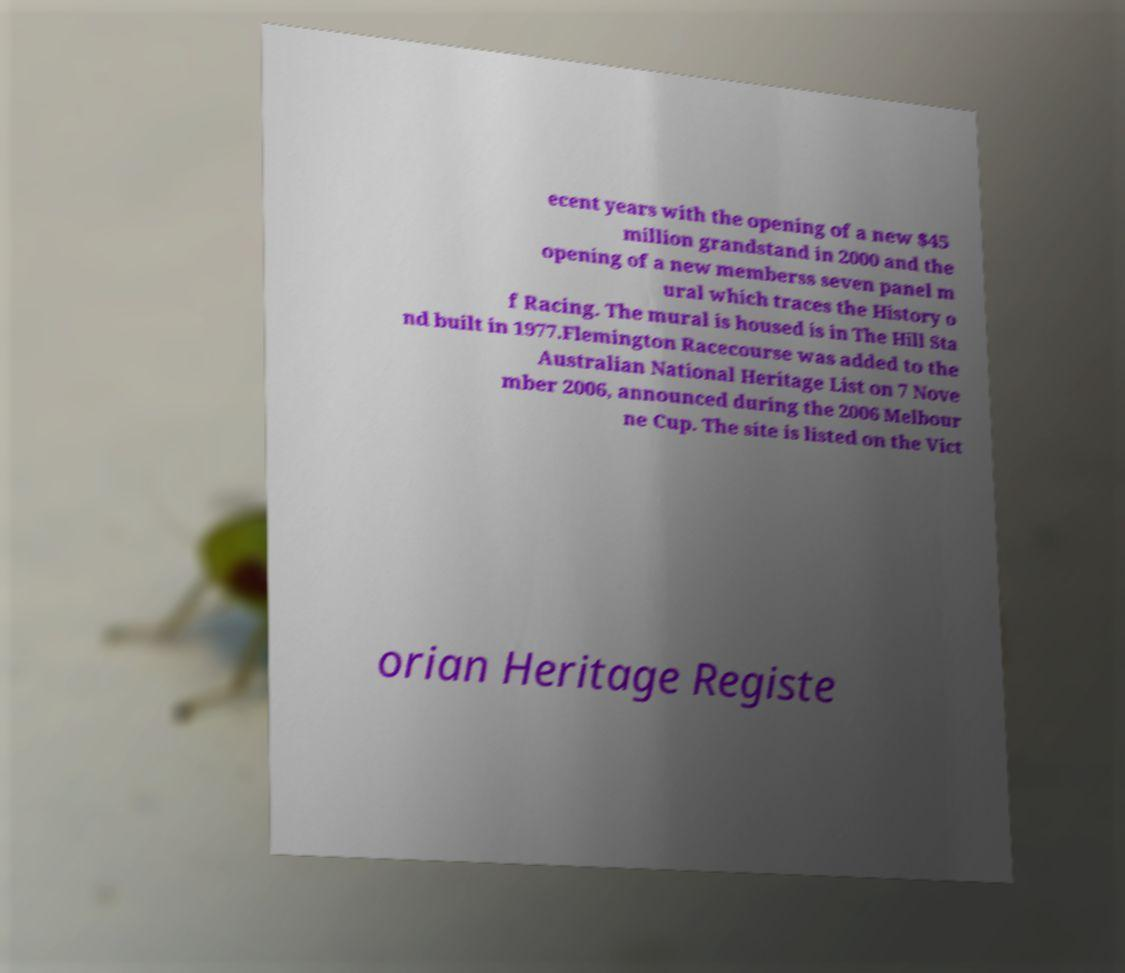What messages or text are displayed in this image? I need them in a readable, typed format. ecent years with the opening of a new $45 million grandstand in 2000 and the opening of a new memberss seven panel m ural which traces the History o f Racing. The mural is housed is in The Hill Sta nd built in 1977.Flemington Racecourse was added to the Australian National Heritage List on 7 Nove mber 2006, announced during the 2006 Melbour ne Cup. The site is listed on the Vict orian Heritage Registe 